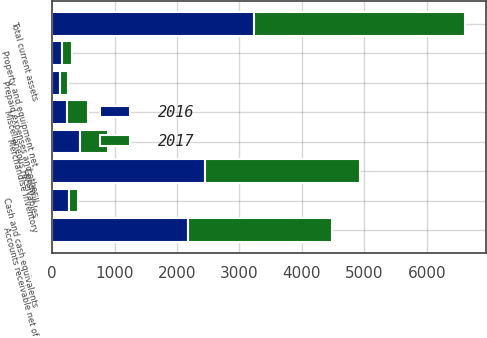Convert chart to OTSL. <chart><loc_0><loc_0><loc_500><loc_500><stacked_bar_chart><ecel><fcel>Cash and cash equivalents<fcel>Accounts receivable net of<fcel>Merchandise inventory<fcel>Miscellaneous receivables<fcel>Prepaid expenses and other<fcel>Total current assets<fcel>Property and equipment net<fcel>Goodwill<nl><fcel>2017<fcel>144.2<fcel>2320.5<fcel>449.5<fcel>336.5<fcel>127.4<fcel>3378.1<fcel>161.1<fcel>2479.6<nl><fcel>2016<fcel>263.7<fcel>2168.6<fcel>452<fcel>234.9<fcel>118.9<fcel>3238.1<fcel>163.7<fcel>2455<nl></chart> 